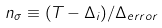Convert formula to latex. <formula><loc_0><loc_0><loc_500><loc_500>n _ { \sigma } \equiv ( T - \Delta _ { i } ) / \Delta _ { e r r o r }</formula> 